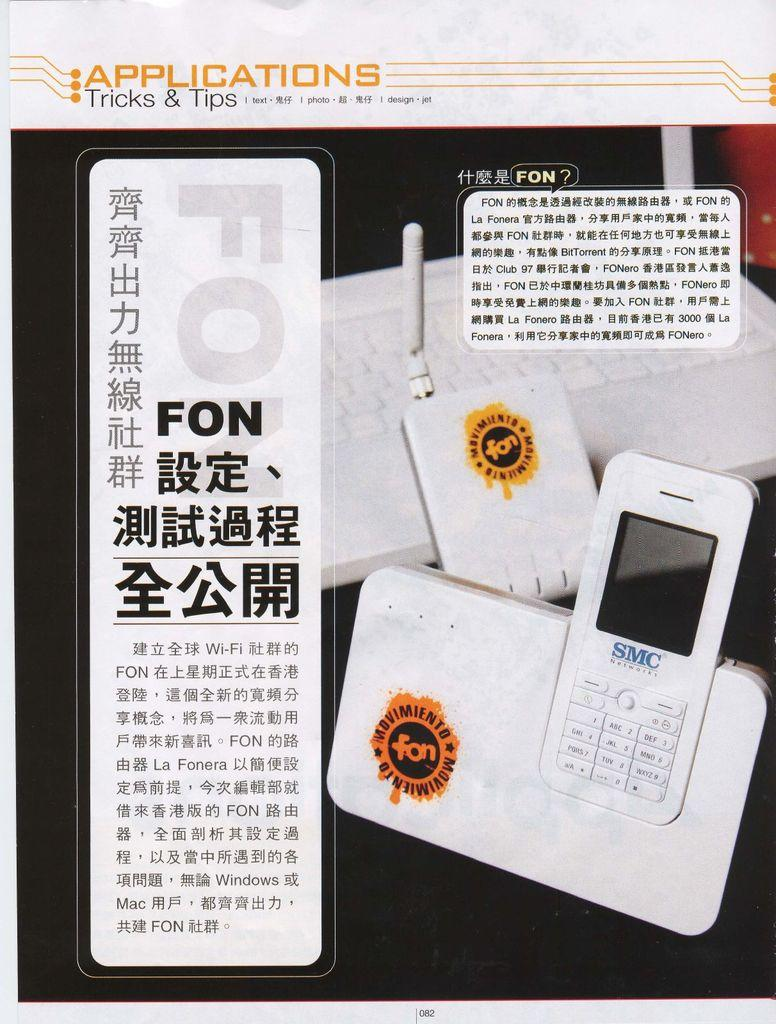<image>
Describe the image concisely. An SMC Networks phone in a charger with a foreign sign next to it. 